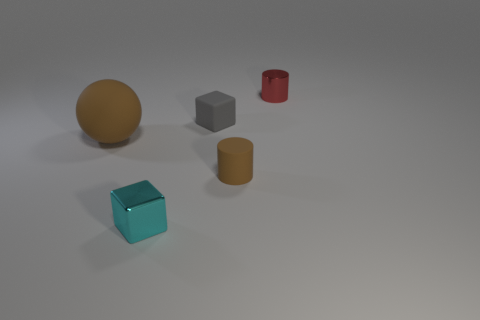Add 1 green metallic objects. How many objects exist? 6 Subtract all balls. How many objects are left? 4 Subtract 0 brown cubes. How many objects are left? 5 Subtract all big matte spheres. Subtract all large brown things. How many objects are left? 3 Add 3 brown matte spheres. How many brown matte spheres are left? 4 Add 2 tiny red cylinders. How many tiny red cylinders exist? 3 